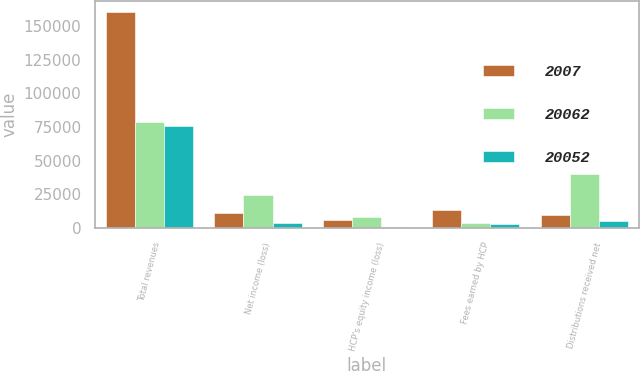Convert chart to OTSL. <chart><loc_0><loc_0><loc_500><loc_500><stacked_bar_chart><ecel><fcel>Total revenues<fcel>Net income (loss)<fcel>HCP's equity income (loss)<fcel>Fees earned by HCP<fcel>Distributions received net<nl><fcel>2007<fcel>160460<fcel>10817<fcel>5645<fcel>13581<fcel>9574<nl><fcel>20062<fcel>78475<fcel>24402<fcel>8331<fcel>3895<fcel>40446<nl><fcel>20052<fcel>75527<fcel>3387<fcel>1123<fcel>3184<fcel>5302<nl></chart> 